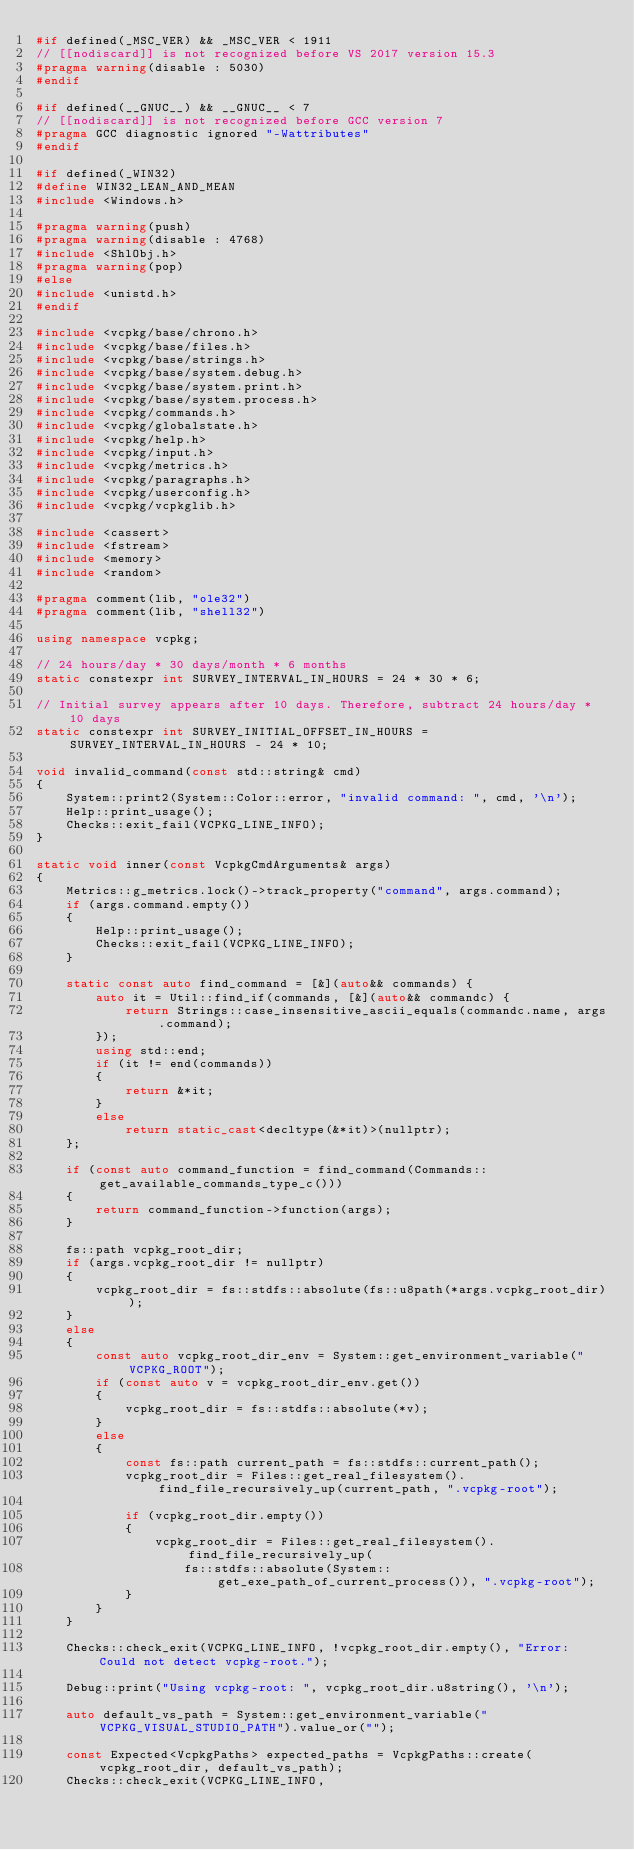Convert code to text. <code><loc_0><loc_0><loc_500><loc_500><_C++_>#if defined(_MSC_VER) && _MSC_VER < 1911
// [[nodiscard]] is not recognized before VS 2017 version 15.3
#pragma warning(disable : 5030)
#endif

#if defined(__GNUC__) && __GNUC__ < 7
// [[nodiscard]] is not recognized before GCC version 7
#pragma GCC diagnostic ignored "-Wattributes"
#endif

#if defined(_WIN32)
#define WIN32_LEAN_AND_MEAN
#include <Windows.h>

#pragma warning(push)
#pragma warning(disable : 4768)
#include <ShlObj.h>
#pragma warning(pop)
#else
#include <unistd.h>
#endif

#include <vcpkg/base/chrono.h>
#include <vcpkg/base/files.h>
#include <vcpkg/base/strings.h>
#include <vcpkg/base/system.debug.h>
#include <vcpkg/base/system.print.h>
#include <vcpkg/base/system.process.h>
#include <vcpkg/commands.h>
#include <vcpkg/globalstate.h>
#include <vcpkg/help.h>
#include <vcpkg/input.h>
#include <vcpkg/metrics.h>
#include <vcpkg/paragraphs.h>
#include <vcpkg/userconfig.h>
#include <vcpkg/vcpkglib.h>

#include <cassert>
#include <fstream>
#include <memory>
#include <random>

#pragma comment(lib, "ole32")
#pragma comment(lib, "shell32")

using namespace vcpkg;

// 24 hours/day * 30 days/month * 6 months
static constexpr int SURVEY_INTERVAL_IN_HOURS = 24 * 30 * 6;

// Initial survey appears after 10 days. Therefore, subtract 24 hours/day * 10 days
static constexpr int SURVEY_INITIAL_OFFSET_IN_HOURS = SURVEY_INTERVAL_IN_HOURS - 24 * 10;

void invalid_command(const std::string& cmd)
{
    System::print2(System::Color::error, "invalid command: ", cmd, '\n');
    Help::print_usage();
    Checks::exit_fail(VCPKG_LINE_INFO);
}

static void inner(const VcpkgCmdArguments& args)
{
    Metrics::g_metrics.lock()->track_property("command", args.command);
    if (args.command.empty())
    {
        Help::print_usage();
        Checks::exit_fail(VCPKG_LINE_INFO);
    }

    static const auto find_command = [&](auto&& commands) {
        auto it = Util::find_if(commands, [&](auto&& commandc) {
            return Strings::case_insensitive_ascii_equals(commandc.name, args.command);
        });
        using std::end;
        if (it != end(commands))
        {
            return &*it;
        }
        else
            return static_cast<decltype(&*it)>(nullptr);
    };

    if (const auto command_function = find_command(Commands::get_available_commands_type_c()))
    {
        return command_function->function(args);
    }

    fs::path vcpkg_root_dir;
    if (args.vcpkg_root_dir != nullptr)
    {
        vcpkg_root_dir = fs::stdfs::absolute(fs::u8path(*args.vcpkg_root_dir));
    }
    else
    {
        const auto vcpkg_root_dir_env = System::get_environment_variable("VCPKG_ROOT");
        if (const auto v = vcpkg_root_dir_env.get())
        {
            vcpkg_root_dir = fs::stdfs::absolute(*v);
        }
        else
        {
            const fs::path current_path = fs::stdfs::current_path();
            vcpkg_root_dir = Files::get_real_filesystem().find_file_recursively_up(current_path, ".vcpkg-root");

            if (vcpkg_root_dir.empty())
            {
                vcpkg_root_dir = Files::get_real_filesystem().find_file_recursively_up(
                    fs::stdfs::absolute(System::get_exe_path_of_current_process()), ".vcpkg-root");
            }
        }
    }

    Checks::check_exit(VCPKG_LINE_INFO, !vcpkg_root_dir.empty(), "Error: Could not detect vcpkg-root.");

    Debug::print("Using vcpkg-root: ", vcpkg_root_dir.u8string(), '\n');

    auto default_vs_path = System::get_environment_variable("VCPKG_VISUAL_STUDIO_PATH").value_or("");

    const Expected<VcpkgPaths> expected_paths = VcpkgPaths::create(vcpkg_root_dir, default_vs_path);
    Checks::check_exit(VCPKG_LINE_INFO,</code> 